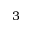Convert formula to latex. <formula><loc_0><loc_0><loc_500><loc_500>3</formula> 